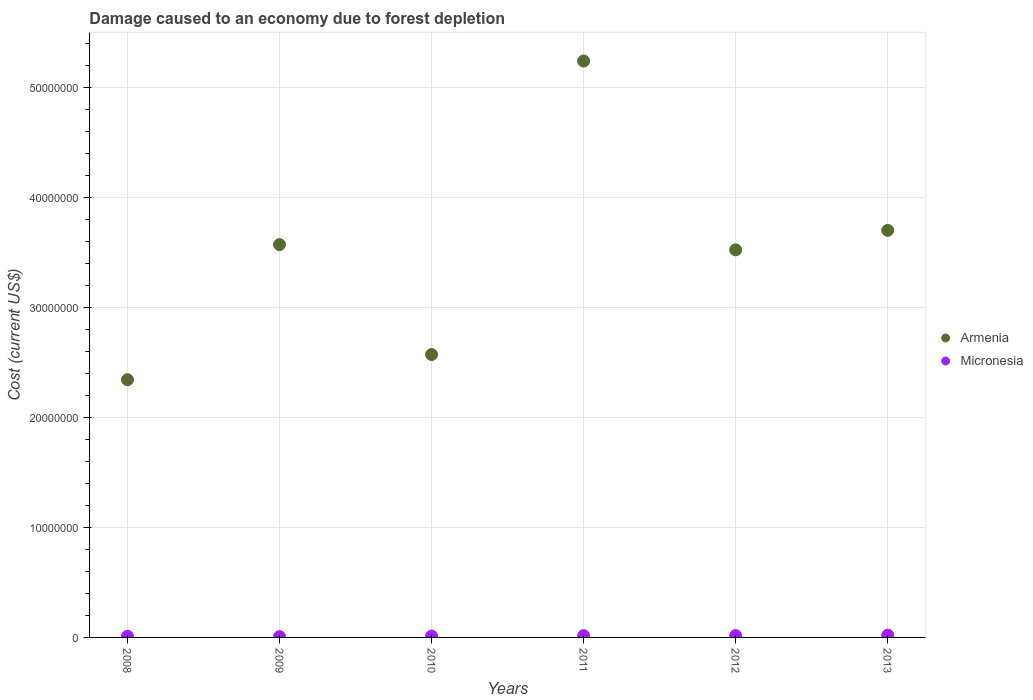How many different coloured dotlines are there?
Your answer should be compact. 2. Is the number of dotlines equal to the number of legend labels?
Offer a very short reply. Yes. What is the cost of damage caused due to forest depletion in Armenia in 2010?
Your response must be concise. 2.57e+07. Across all years, what is the maximum cost of damage caused due to forest depletion in Micronesia?
Your response must be concise. 2.06e+05. Across all years, what is the minimum cost of damage caused due to forest depletion in Micronesia?
Offer a terse response. 7.30e+04. What is the total cost of damage caused due to forest depletion in Micronesia in the graph?
Ensure brevity in your answer.  8.30e+05. What is the difference between the cost of damage caused due to forest depletion in Armenia in 2008 and that in 2013?
Keep it short and to the point. -1.36e+07. What is the difference between the cost of damage caused due to forest depletion in Armenia in 2011 and the cost of damage caused due to forest depletion in Micronesia in 2012?
Make the answer very short. 5.22e+07. What is the average cost of damage caused due to forest depletion in Armenia per year?
Your answer should be compact. 3.49e+07. In the year 2013, what is the difference between the cost of damage caused due to forest depletion in Micronesia and cost of damage caused due to forest depletion in Armenia?
Provide a short and direct response. -3.68e+07. What is the ratio of the cost of damage caused due to forest depletion in Armenia in 2010 to that in 2013?
Your answer should be compact. 0.69. Is the cost of damage caused due to forest depletion in Armenia in 2011 less than that in 2013?
Give a very brief answer. No. Is the difference between the cost of damage caused due to forest depletion in Micronesia in 2008 and 2009 greater than the difference between the cost of damage caused due to forest depletion in Armenia in 2008 and 2009?
Offer a terse response. Yes. What is the difference between the highest and the second highest cost of damage caused due to forest depletion in Armenia?
Your answer should be compact. 1.54e+07. What is the difference between the highest and the lowest cost of damage caused due to forest depletion in Armenia?
Give a very brief answer. 2.90e+07. In how many years, is the cost of damage caused due to forest depletion in Armenia greater than the average cost of damage caused due to forest depletion in Armenia taken over all years?
Keep it short and to the point. 4. Is the sum of the cost of damage caused due to forest depletion in Micronesia in 2011 and 2013 greater than the maximum cost of damage caused due to forest depletion in Armenia across all years?
Provide a short and direct response. No. Is the cost of damage caused due to forest depletion in Micronesia strictly greater than the cost of damage caused due to forest depletion in Armenia over the years?
Your response must be concise. No. Is the cost of damage caused due to forest depletion in Armenia strictly less than the cost of damage caused due to forest depletion in Micronesia over the years?
Give a very brief answer. No. What is the difference between two consecutive major ticks on the Y-axis?
Offer a very short reply. 1.00e+07. Are the values on the major ticks of Y-axis written in scientific E-notation?
Keep it short and to the point. No. Does the graph contain any zero values?
Ensure brevity in your answer.  No. Where does the legend appear in the graph?
Offer a terse response. Center right. What is the title of the graph?
Give a very brief answer. Damage caused to an economy due to forest depletion. What is the label or title of the Y-axis?
Your answer should be very brief. Cost (current US$). What is the Cost (current US$) in Armenia in 2008?
Keep it short and to the point. 2.34e+07. What is the Cost (current US$) of Micronesia in 2008?
Offer a terse response. 1.05e+05. What is the Cost (current US$) of Armenia in 2009?
Your answer should be very brief. 3.57e+07. What is the Cost (current US$) in Micronesia in 2009?
Make the answer very short. 7.30e+04. What is the Cost (current US$) of Armenia in 2010?
Offer a terse response. 2.57e+07. What is the Cost (current US$) in Micronesia in 2010?
Offer a terse response. 1.21e+05. What is the Cost (current US$) of Armenia in 2011?
Ensure brevity in your answer.  5.24e+07. What is the Cost (current US$) of Micronesia in 2011?
Offer a very short reply. 1.58e+05. What is the Cost (current US$) in Armenia in 2012?
Your answer should be very brief. 3.52e+07. What is the Cost (current US$) of Micronesia in 2012?
Offer a very short reply. 1.67e+05. What is the Cost (current US$) of Armenia in 2013?
Provide a succinct answer. 3.70e+07. What is the Cost (current US$) of Micronesia in 2013?
Offer a terse response. 2.06e+05. Across all years, what is the maximum Cost (current US$) of Armenia?
Offer a very short reply. 5.24e+07. Across all years, what is the maximum Cost (current US$) in Micronesia?
Provide a short and direct response. 2.06e+05. Across all years, what is the minimum Cost (current US$) in Armenia?
Your answer should be compact. 2.34e+07. Across all years, what is the minimum Cost (current US$) of Micronesia?
Your response must be concise. 7.30e+04. What is the total Cost (current US$) in Armenia in the graph?
Your response must be concise. 2.09e+08. What is the total Cost (current US$) of Micronesia in the graph?
Make the answer very short. 8.30e+05. What is the difference between the Cost (current US$) in Armenia in 2008 and that in 2009?
Offer a very short reply. -1.23e+07. What is the difference between the Cost (current US$) in Micronesia in 2008 and that in 2009?
Keep it short and to the point. 3.22e+04. What is the difference between the Cost (current US$) in Armenia in 2008 and that in 2010?
Offer a terse response. -2.29e+06. What is the difference between the Cost (current US$) of Micronesia in 2008 and that in 2010?
Your answer should be very brief. -1.61e+04. What is the difference between the Cost (current US$) in Armenia in 2008 and that in 2011?
Give a very brief answer. -2.90e+07. What is the difference between the Cost (current US$) in Micronesia in 2008 and that in 2011?
Offer a very short reply. -5.23e+04. What is the difference between the Cost (current US$) in Armenia in 2008 and that in 2012?
Your answer should be very brief. -1.18e+07. What is the difference between the Cost (current US$) in Micronesia in 2008 and that in 2012?
Offer a terse response. -6.17e+04. What is the difference between the Cost (current US$) in Armenia in 2008 and that in 2013?
Give a very brief answer. -1.36e+07. What is the difference between the Cost (current US$) of Micronesia in 2008 and that in 2013?
Offer a terse response. -1.01e+05. What is the difference between the Cost (current US$) of Armenia in 2009 and that in 2010?
Give a very brief answer. 9.99e+06. What is the difference between the Cost (current US$) of Micronesia in 2009 and that in 2010?
Your response must be concise. -4.83e+04. What is the difference between the Cost (current US$) in Armenia in 2009 and that in 2011?
Provide a succinct answer. -1.67e+07. What is the difference between the Cost (current US$) in Micronesia in 2009 and that in 2011?
Provide a succinct answer. -8.45e+04. What is the difference between the Cost (current US$) of Armenia in 2009 and that in 2012?
Offer a very short reply. 4.78e+05. What is the difference between the Cost (current US$) in Micronesia in 2009 and that in 2012?
Provide a succinct answer. -9.39e+04. What is the difference between the Cost (current US$) in Armenia in 2009 and that in 2013?
Your answer should be compact. -1.30e+06. What is the difference between the Cost (current US$) of Micronesia in 2009 and that in 2013?
Keep it short and to the point. -1.33e+05. What is the difference between the Cost (current US$) in Armenia in 2010 and that in 2011?
Offer a terse response. -2.67e+07. What is the difference between the Cost (current US$) of Micronesia in 2010 and that in 2011?
Offer a very short reply. -3.61e+04. What is the difference between the Cost (current US$) in Armenia in 2010 and that in 2012?
Your answer should be compact. -9.51e+06. What is the difference between the Cost (current US$) in Micronesia in 2010 and that in 2012?
Your answer should be very brief. -4.56e+04. What is the difference between the Cost (current US$) of Armenia in 2010 and that in 2013?
Your answer should be compact. -1.13e+07. What is the difference between the Cost (current US$) of Micronesia in 2010 and that in 2013?
Offer a terse response. -8.49e+04. What is the difference between the Cost (current US$) in Armenia in 2011 and that in 2012?
Your answer should be very brief. 1.72e+07. What is the difference between the Cost (current US$) in Micronesia in 2011 and that in 2012?
Keep it short and to the point. -9425.62. What is the difference between the Cost (current US$) in Armenia in 2011 and that in 2013?
Your answer should be very brief. 1.54e+07. What is the difference between the Cost (current US$) in Micronesia in 2011 and that in 2013?
Provide a short and direct response. -4.88e+04. What is the difference between the Cost (current US$) of Armenia in 2012 and that in 2013?
Your answer should be compact. -1.77e+06. What is the difference between the Cost (current US$) in Micronesia in 2012 and that in 2013?
Offer a terse response. -3.94e+04. What is the difference between the Cost (current US$) of Armenia in 2008 and the Cost (current US$) of Micronesia in 2009?
Offer a very short reply. 2.33e+07. What is the difference between the Cost (current US$) in Armenia in 2008 and the Cost (current US$) in Micronesia in 2010?
Make the answer very short. 2.33e+07. What is the difference between the Cost (current US$) of Armenia in 2008 and the Cost (current US$) of Micronesia in 2011?
Give a very brief answer. 2.33e+07. What is the difference between the Cost (current US$) in Armenia in 2008 and the Cost (current US$) in Micronesia in 2012?
Your answer should be compact. 2.32e+07. What is the difference between the Cost (current US$) of Armenia in 2008 and the Cost (current US$) of Micronesia in 2013?
Your answer should be compact. 2.32e+07. What is the difference between the Cost (current US$) of Armenia in 2009 and the Cost (current US$) of Micronesia in 2010?
Your response must be concise. 3.56e+07. What is the difference between the Cost (current US$) of Armenia in 2009 and the Cost (current US$) of Micronesia in 2011?
Keep it short and to the point. 3.55e+07. What is the difference between the Cost (current US$) in Armenia in 2009 and the Cost (current US$) in Micronesia in 2012?
Offer a very short reply. 3.55e+07. What is the difference between the Cost (current US$) in Armenia in 2009 and the Cost (current US$) in Micronesia in 2013?
Provide a succinct answer. 3.55e+07. What is the difference between the Cost (current US$) of Armenia in 2010 and the Cost (current US$) of Micronesia in 2011?
Provide a short and direct response. 2.55e+07. What is the difference between the Cost (current US$) of Armenia in 2010 and the Cost (current US$) of Micronesia in 2012?
Ensure brevity in your answer.  2.55e+07. What is the difference between the Cost (current US$) of Armenia in 2010 and the Cost (current US$) of Micronesia in 2013?
Your answer should be very brief. 2.55e+07. What is the difference between the Cost (current US$) of Armenia in 2011 and the Cost (current US$) of Micronesia in 2012?
Your answer should be very brief. 5.22e+07. What is the difference between the Cost (current US$) in Armenia in 2011 and the Cost (current US$) in Micronesia in 2013?
Give a very brief answer. 5.22e+07. What is the difference between the Cost (current US$) of Armenia in 2012 and the Cost (current US$) of Micronesia in 2013?
Make the answer very short. 3.50e+07. What is the average Cost (current US$) in Armenia per year?
Provide a succinct answer. 3.49e+07. What is the average Cost (current US$) in Micronesia per year?
Make the answer very short. 1.38e+05. In the year 2008, what is the difference between the Cost (current US$) in Armenia and Cost (current US$) in Micronesia?
Your answer should be compact. 2.33e+07. In the year 2009, what is the difference between the Cost (current US$) of Armenia and Cost (current US$) of Micronesia?
Offer a terse response. 3.56e+07. In the year 2010, what is the difference between the Cost (current US$) of Armenia and Cost (current US$) of Micronesia?
Provide a succinct answer. 2.56e+07. In the year 2011, what is the difference between the Cost (current US$) of Armenia and Cost (current US$) of Micronesia?
Your answer should be very brief. 5.22e+07. In the year 2012, what is the difference between the Cost (current US$) of Armenia and Cost (current US$) of Micronesia?
Your response must be concise. 3.51e+07. In the year 2013, what is the difference between the Cost (current US$) of Armenia and Cost (current US$) of Micronesia?
Make the answer very short. 3.68e+07. What is the ratio of the Cost (current US$) of Armenia in 2008 to that in 2009?
Offer a very short reply. 0.66. What is the ratio of the Cost (current US$) of Micronesia in 2008 to that in 2009?
Your answer should be compact. 1.44. What is the ratio of the Cost (current US$) in Armenia in 2008 to that in 2010?
Offer a terse response. 0.91. What is the ratio of the Cost (current US$) in Micronesia in 2008 to that in 2010?
Offer a very short reply. 0.87. What is the ratio of the Cost (current US$) in Armenia in 2008 to that in 2011?
Ensure brevity in your answer.  0.45. What is the ratio of the Cost (current US$) in Micronesia in 2008 to that in 2011?
Provide a succinct answer. 0.67. What is the ratio of the Cost (current US$) of Armenia in 2008 to that in 2012?
Provide a short and direct response. 0.66. What is the ratio of the Cost (current US$) in Micronesia in 2008 to that in 2012?
Keep it short and to the point. 0.63. What is the ratio of the Cost (current US$) of Armenia in 2008 to that in 2013?
Ensure brevity in your answer.  0.63. What is the ratio of the Cost (current US$) of Micronesia in 2008 to that in 2013?
Offer a terse response. 0.51. What is the ratio of the Cost (current US$) of Armenia in 2009 to that in 2010?
Keep it short and to the point. 1.39. What is the ratio of the Cost (current US$) of Micronesia in 2009 to that in 2010?
Make the answer very short. 0.6. What is the ratio of the Cost (current US$) of Armenia in 2009 to that in 2011?
Make the answer very short. 0.68. What is the ratio of the Cost (current US$) in Micronesia in 2009 to that in 2011?
Provide a short and direct response. 0.46. What is the ratio of the Cost (current US$) of Armenia in 2009 to that in 2012?
Make the answer very short. 1.01. What is the ratio of the Cost (current US$) in Micronesia in 2009 to that in 2012?
Offer a very short reply. 0.44. What is the ratio of the Cost (current US$) in Armenia in 2009 to that in 2013?
Keep it short and to the point. 0.96. What is the ratio of the Cost (current US$) in Micronesia in 2009 to that in 2013?
Give a very brief answer. 0.35. What is the ratio of the Cost (current US$) in Armenia in 2010 to that in 2011?
Offer a terse response. 0.49. What is the ratio of the Cost (current US$) of Micronesia in 2010 to that in 2011?
Provide a succinct answer. 0.77. What is the ratio of the Cost (current US$) of Armenia in 2010 to that in 2012?
Your answer should be compact. 0.73. What is the ratio of the Cost (current US$) of Micronesia in 2010 to that in 2012?
Provide a short and direct response. 0.73. What is the ratio of the Cost (current US$) of Armenia in 2010 to that in 2013?
Make the answer very short. 0.69. What is the ratio of the Cost (current US$) in Micronesia in 2010 to that in 2013?
Give a very brief answer. 0.59. What is the ratio of the Cost (current US$) in Armenia in 2011 to that in 2012?
Keep it short and to the point. 1.49. What is the ratio of the Cost (current US$) of Micronesia in 2011 to that in 2012?
Your response must be concise. 0.94. What is the ratio of the Cost (current US$) in Armenia in 2011 to that in 2013?
Provide a succinct answer. 1.42. What is the ratio of the Cost (current US$) of Micronesia in 2011 to that in 2013?
Your answer should be compact. 0.76. What is the ratio of the Cost (current US$) of Armenia in 2012 to that in 2013?
Ensure brevity in your answer.  0.95. What is the ratio of the Cost (current US$) in Micronesia in 2012 to that in 2013?
Give a very brief answer. 0.81. What is the difference between the highest and the second highest Cost (current US$) of Armenia?
Offer a terse response. 1.54e+07. What is the difference between the highest and the second highest Cost (current US$) of Micronesia?
Offer a terse response. 3.94e+04. What is the difference between the highest and the lowest Cost (current US$) of Armenia?
Your response must be concise. 2.90e+07. What is the difference between the highest and the lowest Cost (current US$) of Micronesia?
Give a very brief answer. 1.33e+05. 